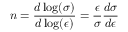Convert formula to latex. <formula><loc_0><loc_0><loc_500><loc_500>n = { \frac { d \log ( \sigma ) } { d \log ( \epsilon ) } } = { \frac { \epsilon } { \sigma } } { \frac { d \sigma } { d \epsilon } } \,</formula> 